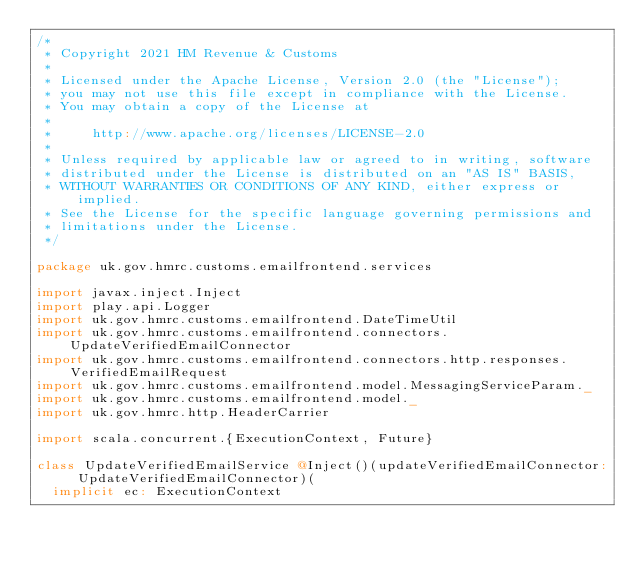<code> <loc_0><loc_0><loc_500><loc_500><_Scala_>/*
 * Copyright 2021 HM Revenue & Customs
 *
 * Licensed under the Apache License, Version 2.0 (the "License");
 * you may not use this file except in compliance with the License.
 * You may obtain a copy of the License at
 *
 *     http://www.apache.org/licenses/LICENSE-2.0
 *
 * Unless required by applicable law or agreed to in writing, software
 * distributed under the License is distributed on an "AS IS" BASIS,
 * WITHOUT WARRANTIES OR CONDITIONS OF ANY KIND, either express or implied.
 * See the License for the specific language governing permissions and
 * limitations under the License.
 */

package uk.gov.hmrc.customs.emailfrontend.services

import javax.inject.Inject
import play.api.Logger
import uk.gov.hmrc.customs.emailfrontend.DateTimeUtil
import uk.gov.hmrc.customs.emailfrontend.connectors.UpdateVerifiedEmailConnector
import uk.gov.hmrc.customs.emailfrontend.connectors.http.responses.VerifiedEmailRequest
import uk.gov.hmrc.customs.emailfrontend.model.MessagingServiceParam._
import uk.gov.hmrc.customs.emailfrontend.model._
import uk.gov.hmrc.http.HeaderCarrier

import scala.concurrent.{ExecutionContext, Future}

class UpdateVerifiedEmailService @Inject()(updateVerifiedEmailConnector: UpdateVerifiedEmailConnector)(
  implicit ec: ExecutionContext</code> 